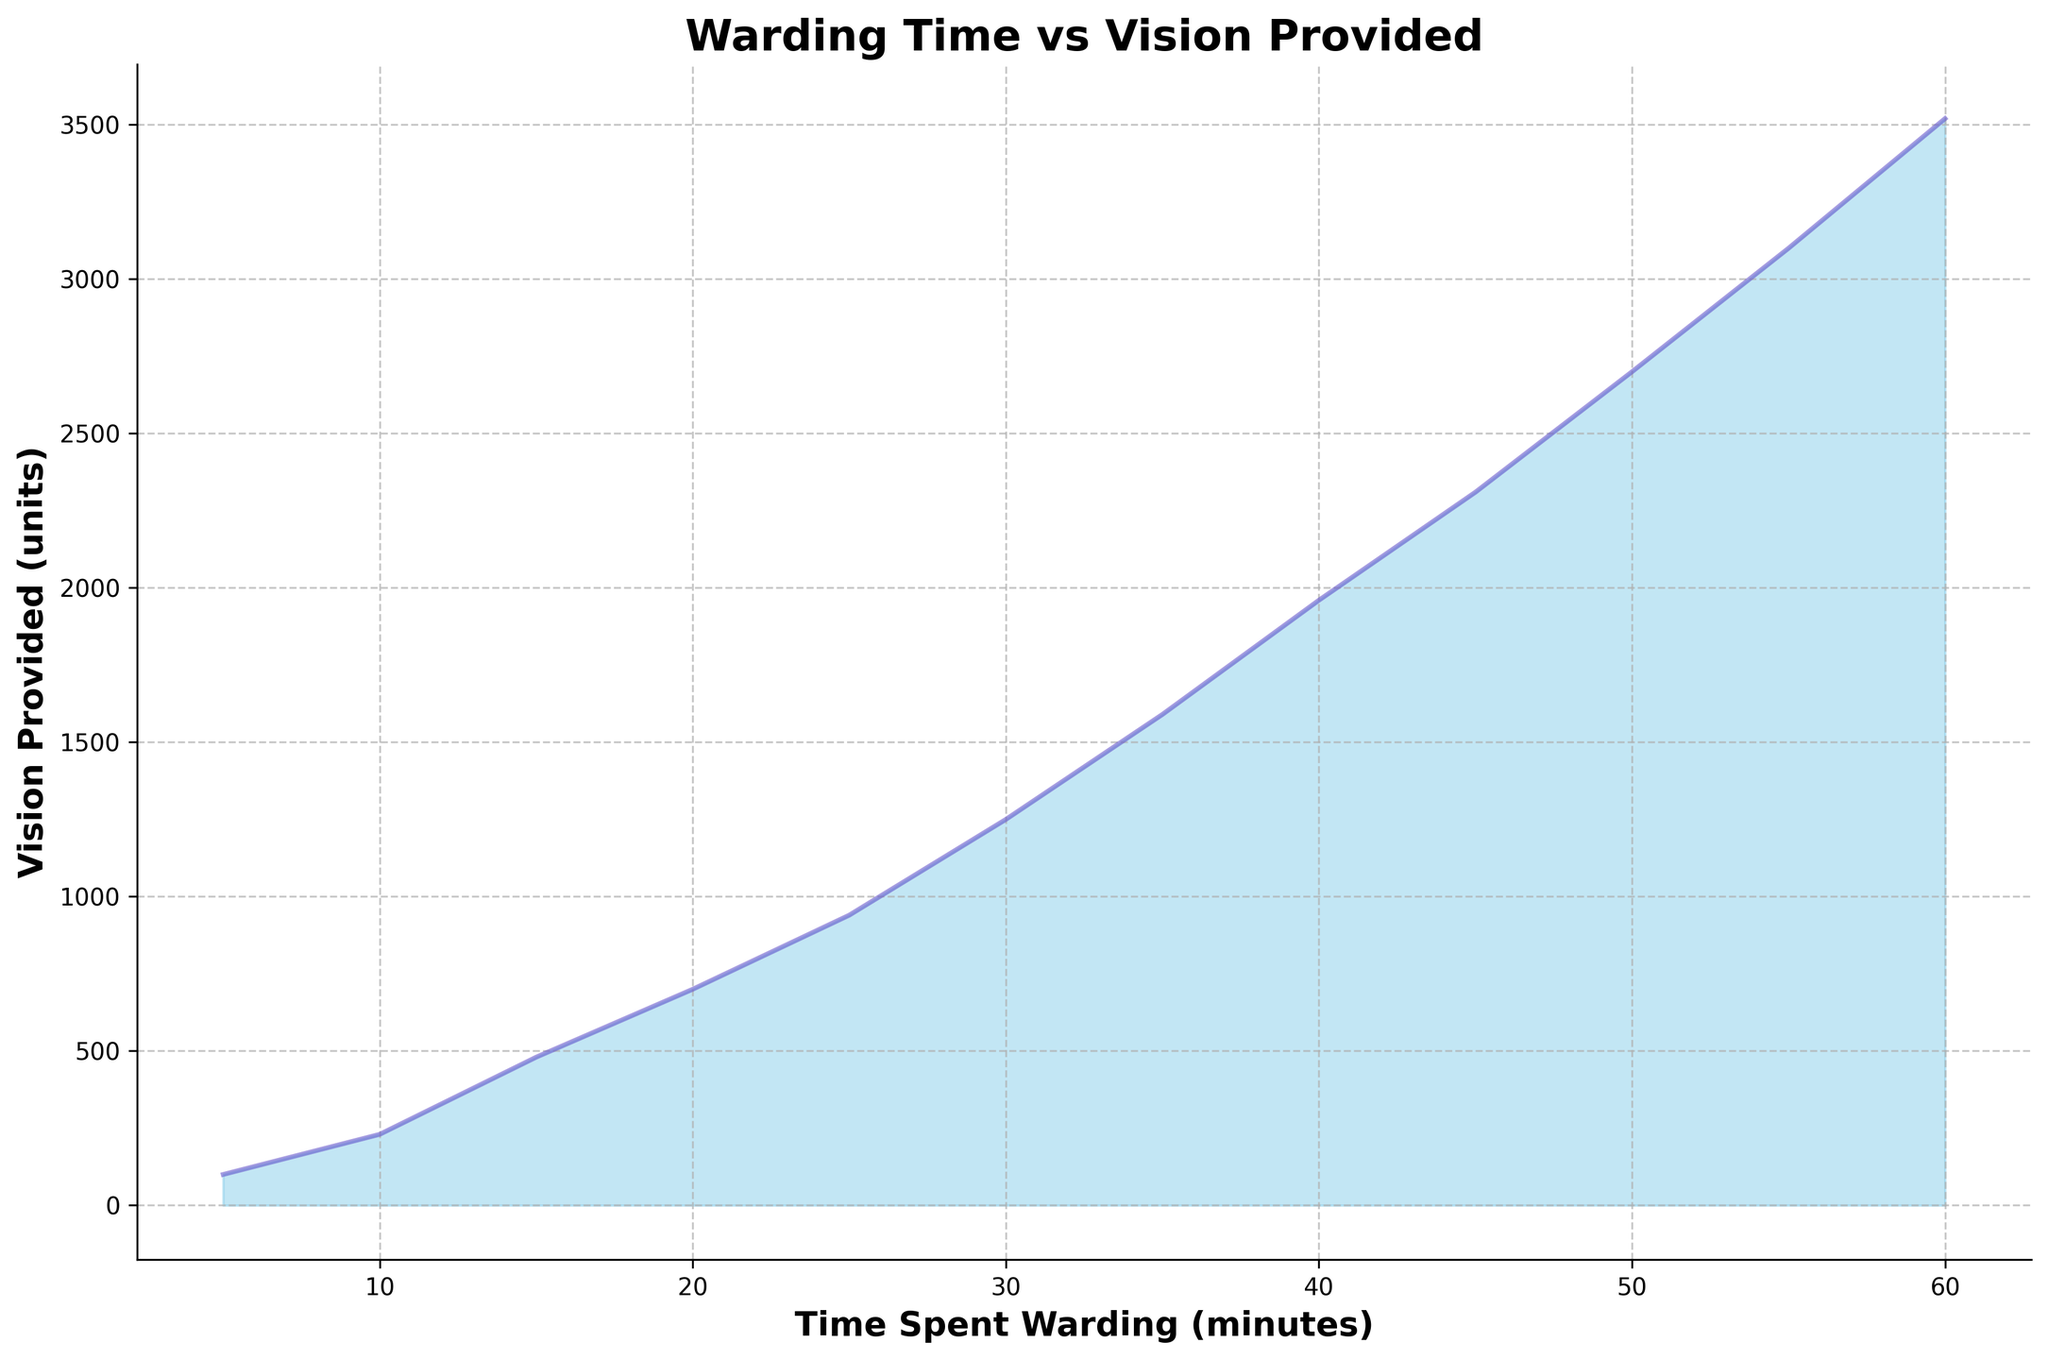What is the amount of vision provided when 30 minutes are spent warding? Locate the point on the x-axis where Time Spent Warding is 30 minutes, then follow it vertically to find the corresponding value on the y-axis. In the chart, this value is 1250 units.
Answer: 1250 How does the vision provided change from 10 minutes to 20 minutes of warding? Find the vision provided at 10 minutes (230 units) and at 20 minutes (700 units). The increase is calculated by subtracting the vision at 10 minutes from the vision at 20 minutes (700 - 230).
Answer: 470 Which time interval shows the largest increase in vision provided in 5 minutes? Compare the differences in vision provided between consecutive 5-minute intervals, e.g., from 5 to 10, 10 to 15, etc. The largest difference is between 55 and 60 minutes (3520 - 3100 = 420 units).
Answer: 55-60 minutes At what point does the vision provided first exceed 2000 units? Move along the curve to see where the y-value surpasses 2000 units. This first occurs between 40 and 45 minutes, specifically at 45 minutes where the value is 2310 units.
Answer: 45 minutes How much more vision is provided at 45 minutes compared to 15 minutes? Find the vision provided at 45 minutes (2310 units) and at 15 minutes (480 units), then subtract the two values (2310 - 480).
Answer: 1830 What is the trend of the vision provided as time spent warding increases? Observe the chart from left to right. The trend demonstrates a steadily increasing curve, indicating that vision provided increases consistently as more time is spent warding.
Answer: Increasing If a support player spent 35 minutes warding, how much vision is provided per minute on average? Find the vision provided at 35 minutes (1590 units). Then divide this by the total time spent warding (35 minutes). The average vision provided per minute is 1590 / 35.
Answer: 45.43 units per minute What is the visual difference between the curve segments from 25 to 30 minutes and 50 to 55 minutes? Compare the steepness and length of the curve segments. The segment from 25 to 30 minutes shows a steady increase, while the segment from 50 to 55 minutes is steeper, indicating a larger increase in vision provided.
Answer: Steeper at 50-55 minutes How would you describe the shape of the area under the curve? The area under the curve gradually rises and becomes more pronounced towards the right side, forming a concave shape that grows steeper as time increases.
Answer: Concave, becoming steeper 